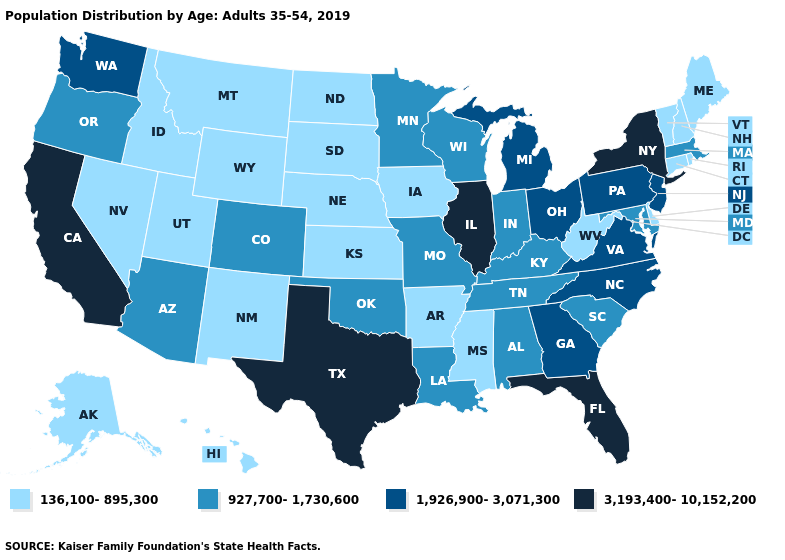What is the highest value in states that border South Dakota?
Write a very short answer. 927,700-1,730,600. Does Missouri have the lowest value in the USA?
Concise answer only. No. What is the lowest value in the Northeast?
Short answer required. 136,100-895,300. What is the value of Nevada?
Quick response, please. 136,100-895,300. Among the states that border Kentucky , which have the lowest value?
Give a very brief answer. West Virginia. Does the first symbol in the legend represent the smallest category?
Keep it brief. Yes. Which states have the lowest value in the South?
Give a very brief answer. Arkansas, Delaware, Mississippi, West Virginia. Name the states that have a value in the range 927,700-1,730,600?
Concise answer only. Alabama, Arizona, Colorado, Indiana, Kentucky, Louisiana, Maryland, Massachusetts, Minnesota, Missouri, Oklahoma, Oregon, South Carolina, Tennessee, Wisconsin. Does Wyoming have the lowest value in the West?
Write a very short answer. Yes. Does Alabama have a higher value than Iowa?
Quick response, please. Yes. Among the states that border New Mexico , does Oklahoma have the lowest value?
Write a very short answer. No. What is the value of Maine?
Give a very brief answer. 136,100-895,300. What is the value of Kentucky?
Be succinct. 927,700-1,730,600. Name the states that have a value in the range 1,926,900-3,071,300?
Concise answer only. Georgia, Michigan, New Jersey, North Carolina, Ohio, Pennsylvania, Virginia, Washington. Among the states that border Virginia , does Tennessee have the highest value?
Quick response, please. No. 